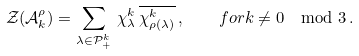Convert formula to latex. <formula><loc_0><loc_0><loc_500><loc_500>\mathcal { Z } ( \mathcal { A } _ { k } ^ { \rho } ) = \sum _ { \lambda \in \mathcal { P } _ { + } ^ { k } } \, \chi _ { \lambda } ^ { k } \, \overline { \chi _ { \rho ( \lambda ) } ^ { k } } \, , \quad f o r k \not = 0 \mod 3 \, .</formula> 